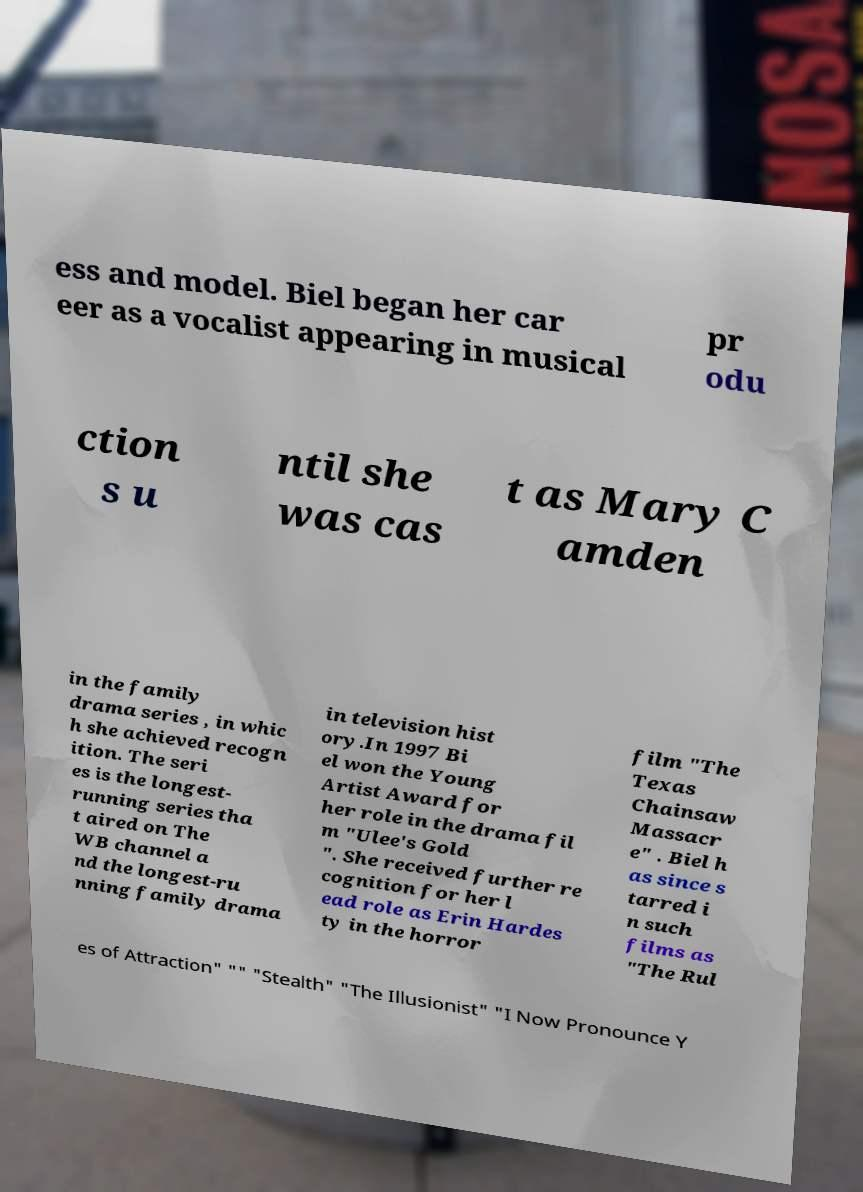For documentation purposes, I need the text within this image transcribed. Could you provide that? ess and model. Biel began her car eer as a vocalist appearing in musical pr odu ction s u ntil she was cas t as Mary C amden in the family drama series , in whic h she achieved recogn ition. The seri es is the longest- running series tha t aired on The WB channel a nd the longest-ru nning family drama in television hist ory.In 1997 Bi el won the Young Artist Award for her role in the drama fil m "Ulee's Gold ". She received further re cognition for her l ead role as Erin Hardes ty in the horror film "The Texas Chainsaw Massacr e" . Biel h as since s tarred i n such films as "The Rul es of Attraction" "" "Stealth" "The Illusionist" "I Now Pronounce Y 